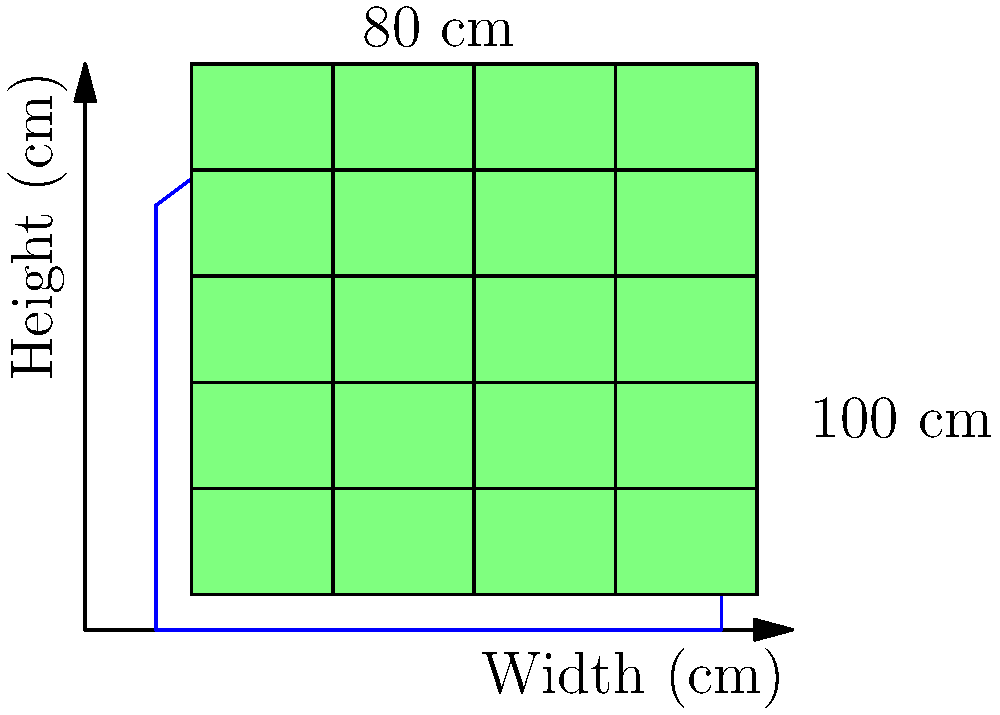A traditional sweater design from your culture measures 100 cm in width and 80 cm in height. The knitting pattern repeat is a 20 cm wide by 15 cm high rectangle. To optimize the use of the pattern, you need to determine the maximum number of complete pattern repeats that can fit within the sweater dimensions, allowing for a 10 cm border on all sides. What is the total number of complete pattern repeats that can be incorporated into the sweater design? To solve this optimization problem, we'll follow these steps:

1. Calculate the available area for the pattern:
   - Width: $100 \text{ cm} - 2 \times 10 \text{ cm} = 80 \text{ cm}$
   - Height: $80 \text{ cm} - 2 \times 10 \text{ cm} = 60 \text{ cm}$

2. Determine the number of pattern repeats that can fit horizontally:
   - $80 \text{ cm} \div 20 \text{ cm} = 4$ pattern repeats

3. Determine the number of pattern repeats that can fit vertically:
   - $60 \text{ cm} \div 15 \text{ cm} = 4$ pattern repeats

4. Calculate the total number of complete pattern repeats:
   - Total repeats $= 4 \times 4 = 16$

Therefore, the maximum number of complete pattern repeats that can be incorporated into the sweater design while maintaining a 10 cm border is 16.
Answer: 16 pattern repeats 